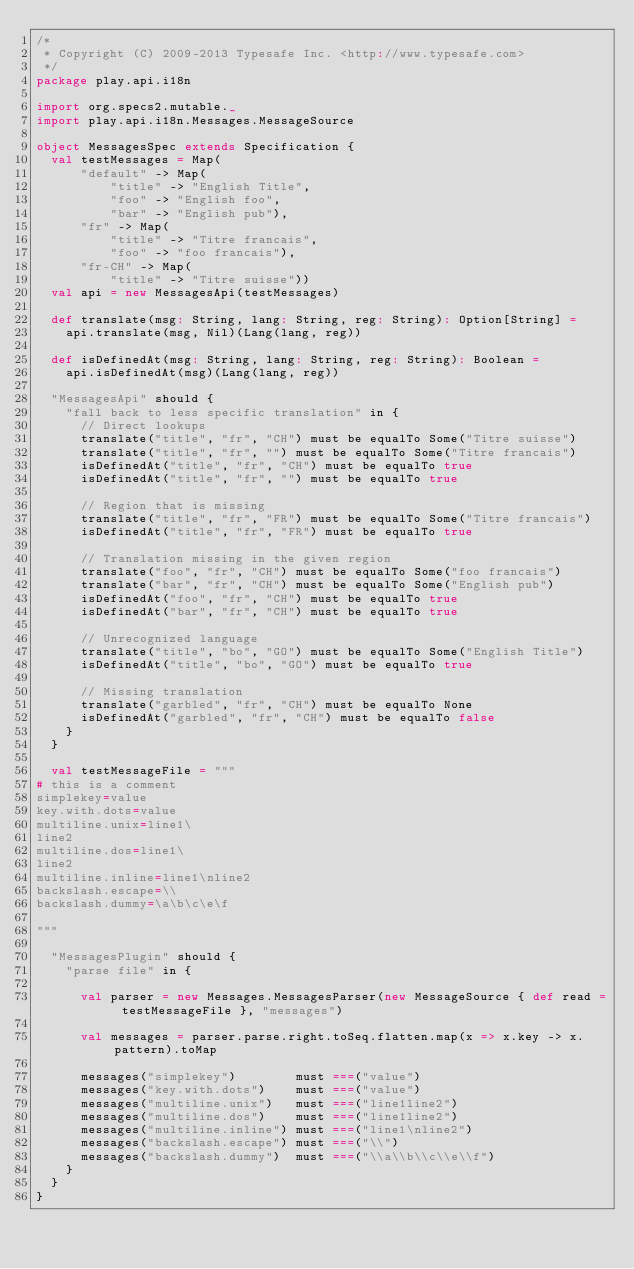Convert code to text. <code><loc_0><loc_0><loc_500><loc_500><_Scala_>/*
 * Copyright (C) 2009-2013 Typesafe Inc. <http://www.typesafe.com>
 */
package play.api.i18n

import org.specs2.mutable._
import play.api.i18n.Messages.MessageSource

object MessagesSpec extends Specification {
  val testMessages = Map(
      "default" -> Map(
          "title" -> "English Title",
          "foo" -> "English foo",
          "bar" -> "English pub"),
      "fr" -> Map(
          "title" -> "Titre francais",
          "foo" -> "foo francais"),
      "fr-CH" -> Map(
          "title" -> "Titre suisse"))
  val api = new MessagesApi(testMessages)

  def translate(msg: String, lang: String, reg: String): Option[String] =
    api.translate(msg, Nil)(Lang(lang, reg))

  def isDefinedAt(msg: String, lang: String, reg: String): Boolean =
    api.isDefinedAt(msg)(Lang(lang, reg))

  "MessagesApi" should {
    "fall back to less specific translation" in {
      // Direct lookups
      translate("title", "fr", "CH") must be equalTo Some("Titre suisse")
      translate("title", "fr", "") must be equalTo Some("Titre francais")
      isDefinedAt("title", "fr", "CH") must be equalTo true
      isDefinedAt("title", "fr", "") must be equalTo true

      // Region that is missing
      translate("title", "fr", "FR") must be equalTo Some("Titre francais")
      isDefinedAt("title", "fr", "FR") must be equalTo true

      // Translation missing in the given region
      translate("foo", "fr", "CH") must be equalTo Some("foo francais")
      translate("bar", "fr", "CH") must be equalTo Some("English pub")
      isDefinedAt("foo", "fr", "CH") must be equalTo true
      isDefinedAt("bar", "fr", "CH") must be equalTo true

      // Unrecognized language
      translate("title", "bo", "GO") must be equalTo Some("English Title")
      isDefinedAt("title", "bo", "GO") must be equalTo true

      // Missing translation
      translate("garbled", "fr", "CH") must be equalTo None
      isDefinedAt("garbled", "fr", "CH") must be equalTo false
    }
  }

  val testMessageFile = """
# this is a comment
simplekey=value
key.with.dots=value
multiline.unix=line1\
line2
multiline.dos=line1\
line2
multiline.inline=line1\nline2
backslash.escape=\\
backslash.dummy=\a\b\c\e\f

"""

  "MessagesPlugin" should {
    "parse file" in {

      val parser = new Messages.MessagesParser(new MessageSource { def read = testMessageFile }, "messages")

      val messages = parser.parse.right.toSeq.flatten.map(x => x.key -> x.pattern).toMap

      messages("simplekey")        must ===("value")
      messages("key.with.dots")    must ===("value")
      messages("multiline.unix")   must ===("line1line2")
      messages("multiline.dos")    must ===("line1line2")
      messages("multiline.inline") must ===("line1\nline2")
      messages("backslash.escape") must ===("\\")
      messages("backslash.dummy")  must ===("\\a\\b\\c\\e\\f")
    }
  }
}
</code> 